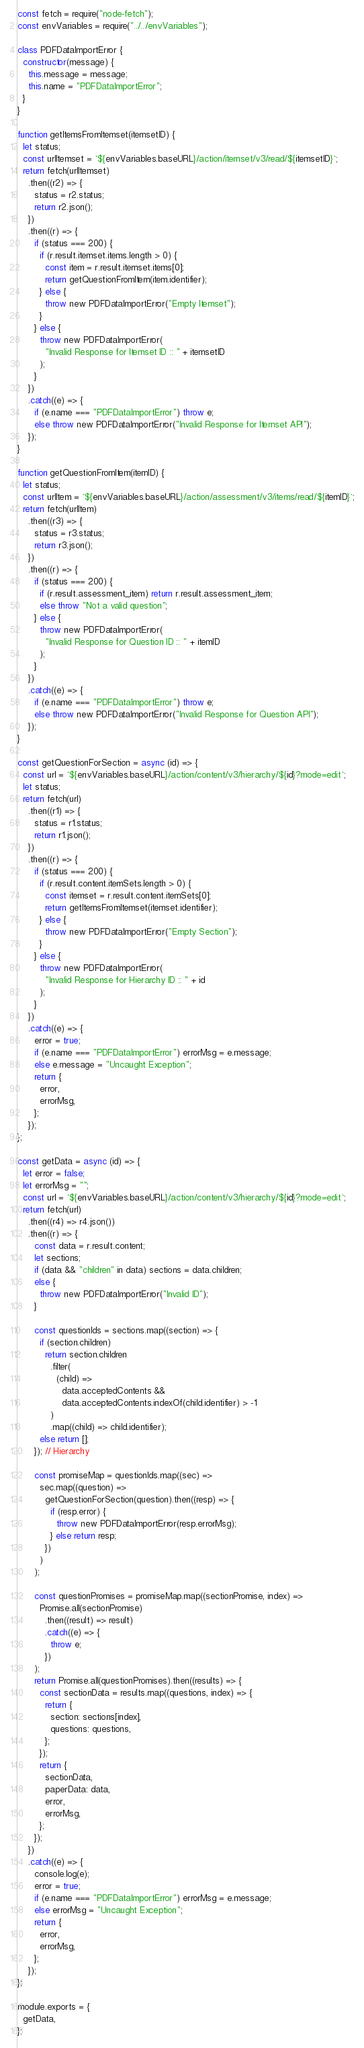Convert code to text. <code><loc_0><loc_0><loc_500><loc_500><_JavaScript_>const fetch = require("node-fetch");
const envVariables = require("../../envVariables");

class PDFDataImportError {
  constructor(message) {
    this.message = message;
    this.name = "PDFDataImportError";
  }
}

function getItemsFromItemset(itemsetID) {
  let status;
  const urlItemset = `${envVariables.baseURL}/action/itemset/v3/read/${itemsetID}`;
  return fetch(urlItemset)
    .then((r2) => {
      status = r2.status;
      return r2.json();
    })
    .then((r) => {
      if (status === 200) {
        if (r.result.itemset.items.length > 0) {
          const item = r.result.itemset.items[0];
          return getQuestionFromItem(item.identifier);
        } else {
          throw new PDFDataImportError("Empty Itemset");
        }
      } else {
        throw new PDFDataImportError(
          "Invalid Response for Itemset ID :: " + itemsetID
        );
      }
    })
    .catch((e) => {
      if (e.name === "PDFDataImportError") throw e;
      else throw new PDFDataImportError("Invalid Response for Itemset API");
    });
}

function getQuestionFromItem(itemID) {
  let status;
  const urlItem = `${envVariables.baseURL}/action/assessment/v3/items/read/${itemID}`;
  return fetch(urlItem)
    .then((r3) => {
      status = r3.status;
      return r3.json();
    })
    .then((r) => {
      if (status === 200) {
        if (r.result.assessment_item) return r.result.assessment_item;
        else throw "Not a valid question";
      } else {
        throw new PDFDataImportError(
          "Invalid Response for Question ID :: " + itemID
        );
      }
    })
    .catch((e) => {
      if (e.name === "PDFDataImportError") throw e;
      else throw new PDFDataImportError("Invalid Response for Question API");
    });
}

const getQuestionForSection = async (id) => {
  const url = `${envVariables.baseURL}/action/content/v3/hierarchy/${id}?mode=edit`;
  let status;
  return fetch(url)
    .then((r1) => {
      status = r1.status;
      return r1.json();
    })
    .then((r) => {
      if (status === 200) {
        if (r.result.content.itemSets.length > 0) {
          const itemset = r.result.content.itemSets[0];
          return getItemsFromItemset(itemset.identifier);
        } else {
          throw new PDFDataImportError("Empty Section");
        }
      } else {
        throw new PDFDataImportError(
          "Invalid Response for Hierarchy ID :: " + id
        );
      }
    })
    .catch((e) => {
      error = true;
      if (e.name === "PDFDataImportError") errorMsg = e.message;
      else e.message = "Uncaught Exception";
      return {
        error,
        errorMsg,
      };
    });
};

const getData = async (id) => {
  let error = false;
  let errorMsg = "";
  const url = `${envVariables.baseURL}/action/content/v3/hierarchy/${id}?mode=edit`;
  return fetch(url)
    .then((r4) => r4.json())
    .then((r) => {
      const data = r.result.content;
      let sections;
      if (data && "children" in data) sections = data.children;
      else {
        throw new PDFDataImportError("Invalid ID");
      }

      const questionIds = sections.map((section) => {
        if (section.children)
          return section.children
            .filter(
              (child) =>
                data.acceptedContents &&
                data.acceptedContents.indexOf(child.identifier) > -1
            )
            .map((child) => child.identifier);
        else return [];
      }); // Hierarchy

      const promiseMap = questionIds.map((sec) =>
        sec.map((question) =>
          getQuestionForSection(question).then((resp) => {
            if (resp.error) {
              throw new PDFDataImportError(resp.errorMsg);
            } else return resp;
          })
        )
      );

      const questionPromises = promiseMap.map((sectionPromise, index) =>
        Promise.all(sectionPromise)
          .then((result) => result)
          .catch((e) => {
            throw e;
          })
      );
      return Promise.all(questionPromises).then((results) => {
        const sectionData = results.map((questions, index) => {
          return {
            section: sections[index],
            questions: questions,
          };
        });
        return {
          sectionData,
          paperData: data,
          error,
          errorMsg,
        };
      });
    })
    .catch((e) => {
      console.log(e);
      error = true;
      if (e.name === "PDFDataImportError") errorMsg = e.message;
      else errorMsg = "Uncaught Exception";
      return {
        error,
        errorMsg,
      };
    });
};

module.exports = {
  getData,
};
</code> 